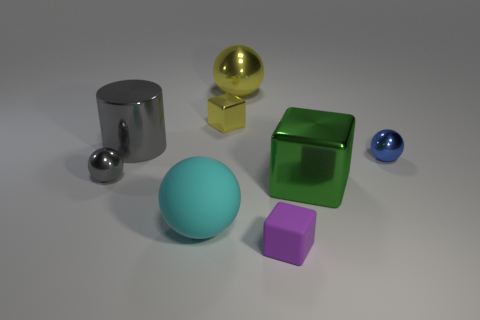Is there anything else that has the same color as the big metallic sphere?
Provide a short and direct response. Yes. There is a cyan thing that is the same material as the tiny purple cube; what is its size?
Your response must be concise. Large. There is a tiny sphere behind the tiny sphere that is on the left side of the tiny block in front of the large cyan rubber object; what is its material?
Ensure brevity in your answer.  Metal. Is the number of large green shiny objects less than the number of big purple metal spheres?
Offer a terse response. No. Are the green cube and the yellow cube made of the same material?
Your answer should be very brief. Yes. What shape is the shiny object that is the same color as the cylinder?
Give a very brief answer. Sphere. There is a small metal thing to the right of the large metallic block; is its color the same as the tiny matte cube?
Keep it short and to the point. No. How many blocks are on the right side of the large sphere that is to the right of the big cyan object?
Offer a very short reply. 2. The metal ball that is the same size as the gray metal cylinder is what color?
Your answer should be compact. Yellow. What is the small sphere to the right of the gray metal sphere made of?
Give a very brief answer. Metal. 